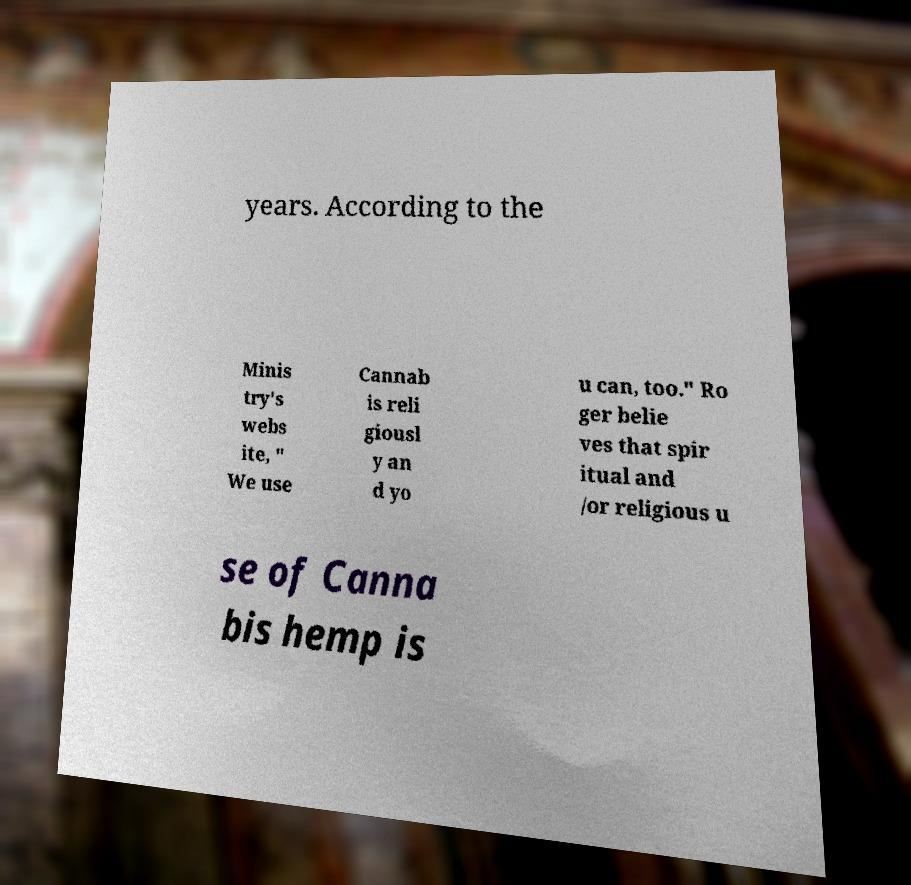Can you accurately transcribe the text from the provided image for me? years. According to the Minis try's webs ite, " We use Cannab is reli giousl y an d yo u can, too." Ro ger belie ves that spir itual and /or religious u se of Canna bis hemp is 